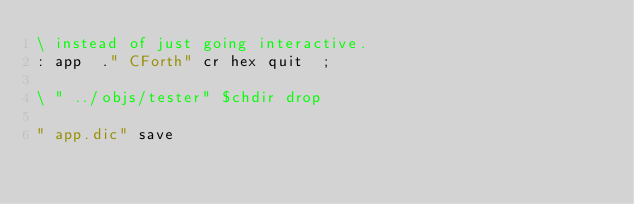<code> <loc_0><loc_0><loc_500><loc_500><_Forth_>\ instead of just going interactive.
: app  ." CForth" cr hex quit  ;

\ " ../objs/tester" $chdir drop

" app.dic" save
</code> 